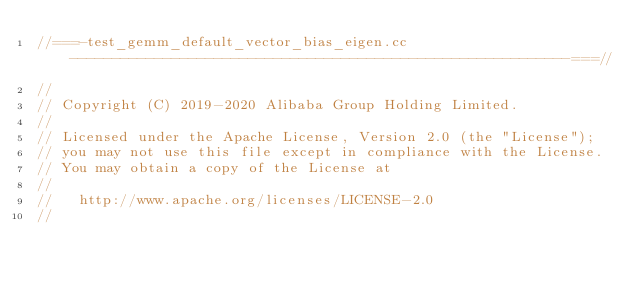Convert code to text. <code><loc_0><loc_0><loc_500><loc_500><_C++_>//===-test_gemm_default_vector_bias_eigen.cc-----------------------------------------------------------===//
//
// Copyright (C) 2019-2020 Alibaba Group Holding Limited.
//
// Licensed under the Apache License, Version 2.0 (the "License");
// you may not use this file except in compliance with the License.
// You may obtain a copy of the License at
//
//   http://www.apache.org/licenses/LICENSE-2.0
//</code> 